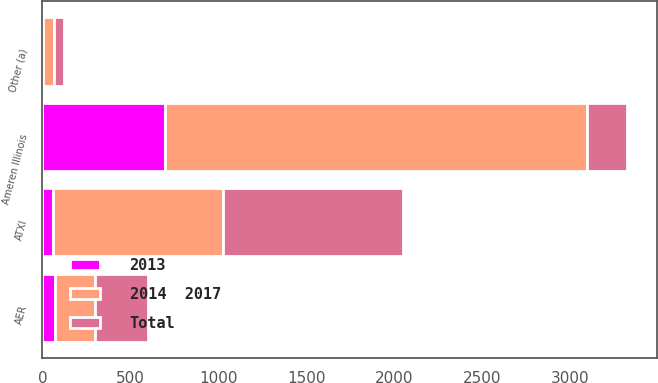Convert chart to OTSL. <chart><loc_0><loc_0><loc_500><loc_500><stacked_bar_chart><ecel><fcel>Ameren Illinois<fcel>AER<fcel>ATXI<fcel>Other (a)<nl><fcel>2013<fcel>695<fcel>70<fcel>60<fcel>5<nl><fcel>2014  2017<fcel>2400<fcel>230<fcel>965<fcel>60<nl><fcel>Total<fcel>230<fcel>300<fcel>1025<fcel>55<nl></chart> 